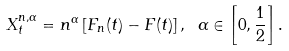<formula> <loc_0><loc_0><loc_500><loc_500>X ^ { n , \alpha } _ { t } = n ^ { \alpha } \left [ F _ { n } ( t ) - F ( t ) \right ] , \ \alpha \in \left [ 0 , \frac { 1 } { 2 } \right ] .</formula> 